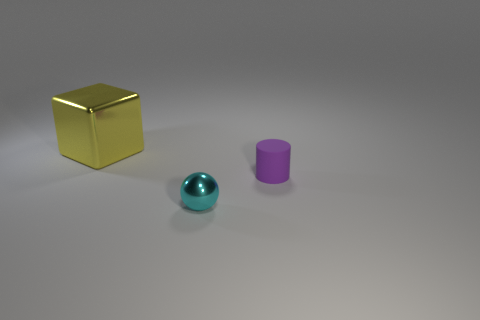What number of red objects are small rubber cylinders or small metallic balls?
Make the answer very short. 0. How many big things have the same shape as the small purple rubber thing?
Keep it short and to the point. 0. How many spheres are the same size as the cyan metal object?
Provide a short and direct response. 0. The tiny object behind the metal sphere is what color?
Provide a succinct answer. Purple. Are there more objects that are on the left side of the rubber cylinder than gray balls?
Make the answer very short. Yes. The cube is what color?
Keep it short and to the point. Yellow. There is a metallic thing that is on the left side of the metal thing that is in front of the object behind the matte cylinder; what is its shape?
Provide a short and direct response. Cube. The object that is on the left side of the rubber object and behind the ball is made of what material?
Your answer should be very brief. Metal. What is the shape of the small object right of the metal thing in front of the yellow shiny cube?
Give a very brief answer. Cylinder. Is there any other thing that is the same color as the matte object?
Make the answer very short. No. 